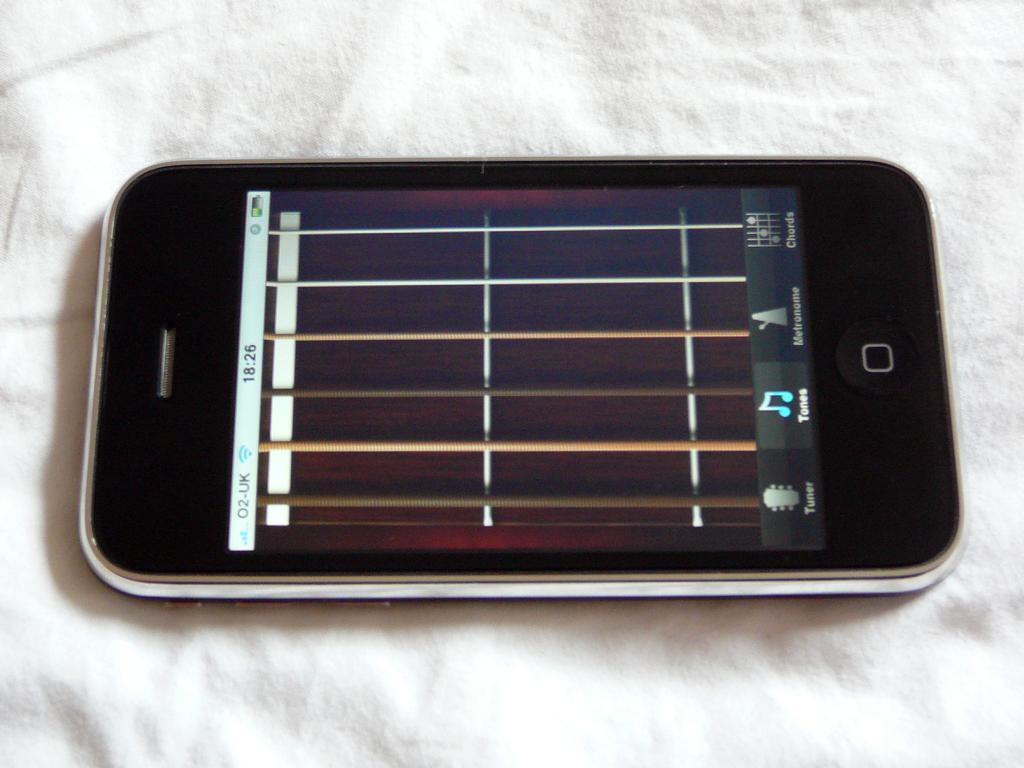What time is on the phone?
Your response must be concise. 18:26. 